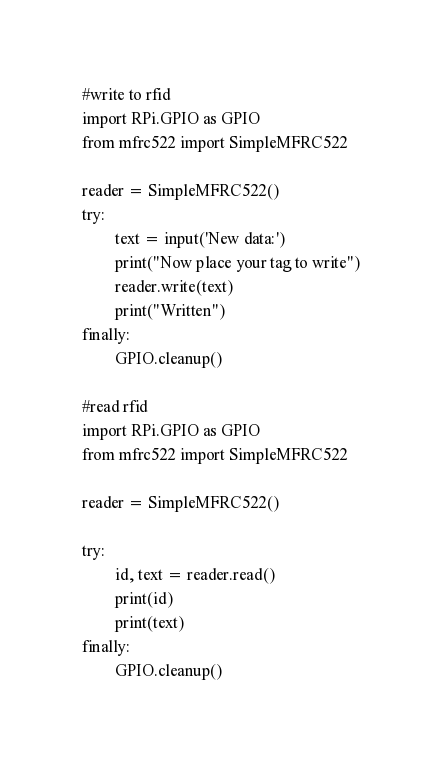<code> <loc_0><loc_0><loc_500><loc_500><_Python_>#write to rfid
import RPi.GPIO as GPIO
from mfrc522 import SimpleMFRC522

reader = SimpleMFRC522()
try:
        text = input('New data:')
        print("Now place your tag to write")
        reader.write(text)
        print("Written")
finally:
        GPIO.cleanup()

#read rfid
import RPi.GPIO as GPIO
from mfrc522 import SimpleMFRC522

reader = SimpleMFRC522()

try:
        id, text = reader.read()
        print(id)
        print(text)
finally:
        GPIO.cleanup()</code> 